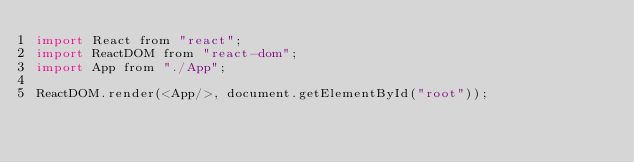Convert code to text. <code><loc_0><loc_0><loc_500><loc_500><_JavaScript_>import React from "react";
import ReactDOM from "react-dom";
import App from "./App";

ReactDOM.render(<App/>, document.getElementById("root"));
</code> 